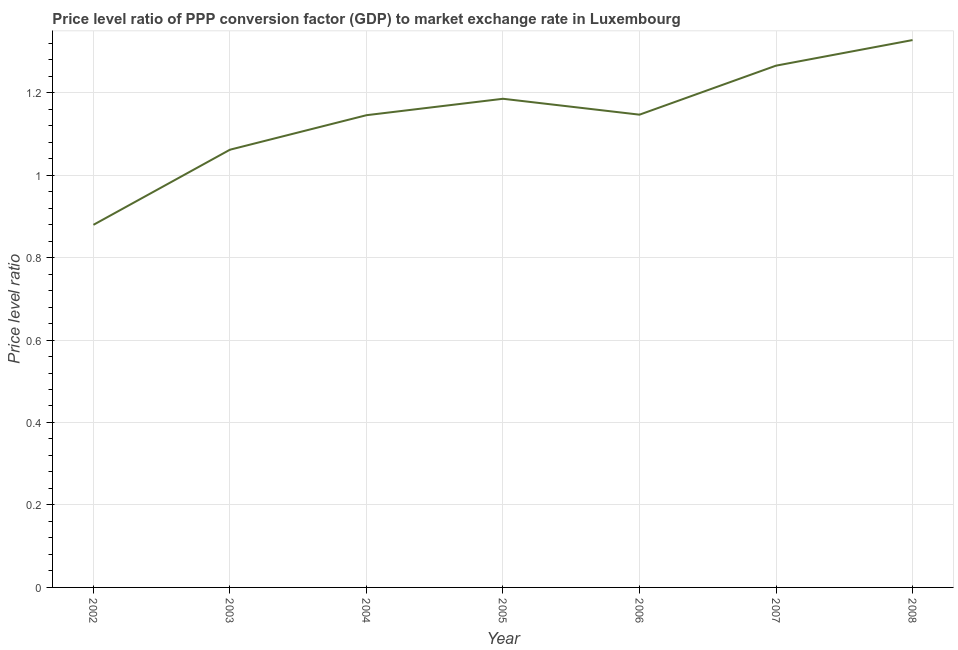What is the price level ratio in 2002?
Keep it short and to the point. 0.88. Across all years, what is the maximum price level ratio?
Keep it short and to the point. 1.33. Across all years, what is the minimum price level ratio?
Ensure brevity in your answer.  0.88. What is the sum of the price level ratio?
Offer a terse response. 8.01. What is the difference between the price level ratio in 2002 and 2006?
Keep it short and to the point. -0.27. What is the average price level ratio per year?
Your answer should be compact. 1.14. What is the median price level ratio?
Offer a terse response. 1.15. In how many years, is the price level ratio greater than 0.52 ?
Your answer should be very brief. 7. What is the ratio of the price level ratio in 2002 to that in 2005?
Keep it short and to the point. 0.74. Is the difference between the price level ratio in 2006 and 2007 greater than the difference between any two years?
Offer a very short reply. No. What is the difference between the highest and the second highest price level ratio?
Provide a short and direct response. 0.06. What is the difference between the highest and the lowest price level ratio?
Provide a short and direct response. 0.45. How many lines are there?
Ensure brevity in your answer.  1. How many years are there in the graph?
Give a very brief answer. 7. Does the graph contain any zero values?
Offer a very short reply. No. What is the title of the graph?
Your response must be concise. Price level ratio of PPP conversion factor (GDP) to market exchange rate in Luxembourg. What is the label or title of the X-axis?
Your response must be concise. Year. What is the label or title of the Y-axis?
Provide a succinct answer. Price level ratio. What is the Price level ratio in 2002?
Offer a terse response. 0.88. What is the Price level ratio of 2003?
Your response must be concise. 1.06. What is the Price level ratio of 2004?
Keep it short and to the point. 1.15. What is the Price level ratio of 2005?
Your answer should be compact. 1.19. What is the Price level ratio of 2006?
Make the answer very short. 1.15. What is the Price level ratio of 2007?
Your answer should be compact. 1.27. What is the Price level ratio of 2008?
Give a very brief answer. 1.33. What is the difference between the Price level ratio in 2002 and 2003?
Your response must be concise. -0.18. What is the difference between the Price level ratio in 2002 and 2004?
Make the answer very short. -0.27. What is the difference between the Price level ratio in 2002 and 2005?
Offer a very short reply. -0.31. What is the difference between the Price level ratio in 2002 and 2006?
Offer a terse response. -0.27. What is the difference between the Price level ratio in 2002 and 2007?
Your response must be concise. -0.39. What is the difference between the Price level ratio in 2002 and 2008?
Provide a succinct answer. -0.45. What is the difference between the Price level ratio in 2003 and 2004?
Give a very brief answer. -0.08. What is the difference between the Price level ratio in 2003 and 2005?
Provide a succinct answer. -0.12. What is the difference between the Price level ratio in 2003 and 2006?
Make the answer very short. -0.08. What is the difference between the Price level ratio in 2003 and 2007?
Provide a short and direct response. -0.2. What is the difference between the Price level ratio in 2003 and 2008?
Ensure brevity in your answer.  -0.27. What is the difference between the Price level ratio in 2004 and 2005?
Your answer should be compact. -0.04. What is the difference between the Price level ratio in 2004 and 2006?
Offer a terse response. -0. What is the difference between the Price level ratio in 2004 and 2007?
Offer a very short reply. -0.12. What is the difference between the Price level ratio in 2004 and 2008?
Offer a very short reply. -0.18. What is the difference between the Price level ratio in 2005 and 2006?
Offer a very short reply. 0.04. What is the difference between the Price level ratio in 2005 and 2007?
Provide a succinct answer. -0.08. What is the difference between the Price level ratio in 2005 and 2008?
Give a very brief answer. -0.14. What is the difference between the Price level ratio in 2006 and 2007?
Your answer should be very brief. -0.12. What is the difference between the Price level ratio in 2006 and 2008?
Keep it short and to the point. -0.18. What is the difference between the Price level ratio in 2007 and 2008?
Keep it short and to the point. -0.06. What is the ratio of the Price level ratio in 2002 to that in 2003?
Your answer should be very brief. 0.83. What is the ratio of the Price level ratio in 2002 to that in 2004?
Your answer should be compact. 0.77. What is the ratio of the Price level ratio in 2002 to that in 2005?
Your answer should be compact. 0.74. What is the ratio of the Price level ratio in 2002 to that in 2006?
Ensure brevity in your answer.  0.77. What is the ratio of the Price level ratio in 2002 to that in 2007?
Your answer should be compact. 0.69. What is the ratio of the Price level ratio in 2002 to that in 2008?
Your answer should be very brief. 0.66. What is the ratio of the Price level ratio in 2003 to that in 2004?
Offer a very short reply. 0.93. What is the ratio of the Price level ratio in 2003 to that in 2005?
Offer a very short reply. 0.9. What is the ratio of the Price level ratio in 2003 to that in 2006?
Your answer should be very brief. 0.93. What is the ratio of the Price level ratio in 2003 to that in 2007?
Keep it short and to the point. 0.84. What is the ratio of the Price level ratio in 2003 to that in 2008?
Your answer should be compact. 0.8. What is the ratio of the Price level ratio in 2004 to that in 2006?
Provide a short and direct response. 1. What is the ratio of the Price level ratio in 2004 to that in 2007?
Provide a succinct answer. 0.91. What is the ratio of the Price level ratio in 2004 to that in 2008?
Your answer should be compact. 0.86. What is the ratio of the Price level ratio in 2005 to that in 2006?
Provide a short and direct response. 1.03. What is the ratio of the Price level ratio in 2005 to that in 2007?
Give a very brief answer. 0.94. What is the ratio of the Price level ratio in 2005 to that in 2008?
Your response must be concise. 0.89. What is the ratio of the Price level ratio in 2006 to that in 2007?
Your response must be concise. 0.91. What is the ratio of the Price level ratio in 2006 to that in 2008?
Make the answer very short. 0.86. What is the ratio of the Price level ratio in 2007 to that in 2008?
Offer a terse response. 0.95. 